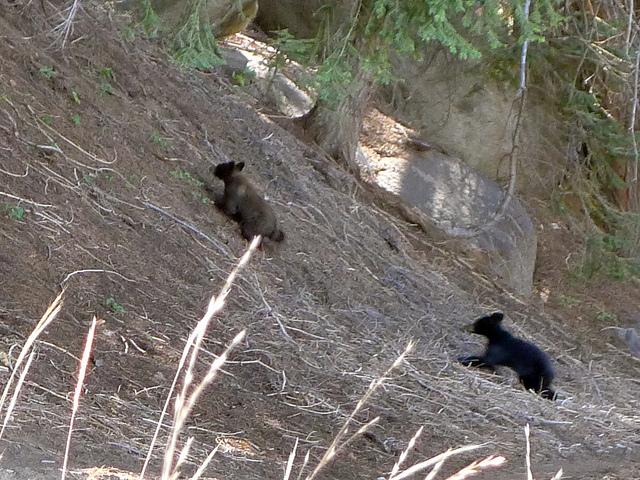What animal is this?
Give a very brief answer. Bear. Are these bears running into the woods?
Quick response, please. Yes. What is the bear doing?
Keep it brief. Running. Why do you think the mother may be close by?
Concise answer only. Never far behind. Is this a bird?
Give a very brief answer. No. Are the animals dogs?
Short answer required. No. 